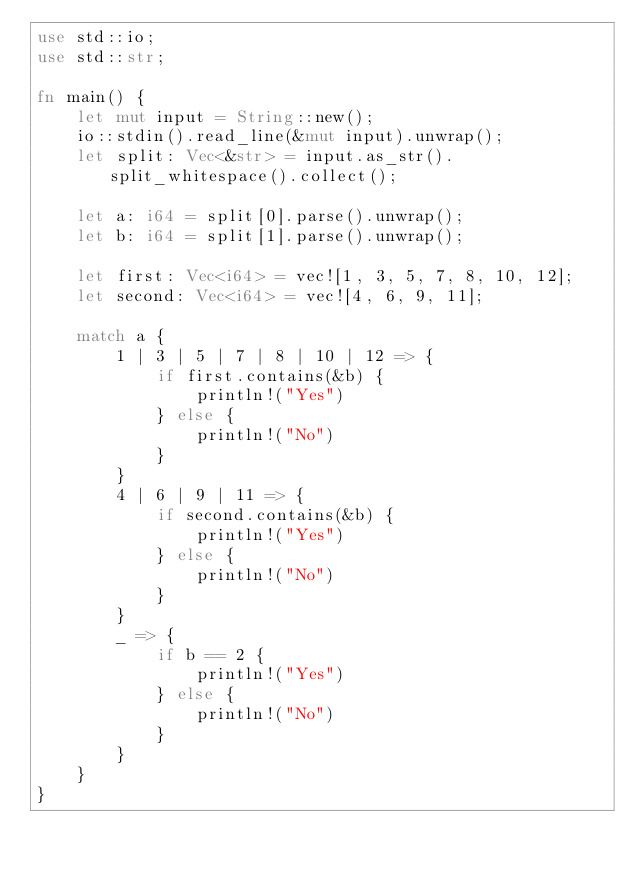<code> <loc_0><loc_0><loc_500><loc_500><_Rust_>use std::io;
use std::str;

fn main() {
    let mut input = String::new();
    io::stdin().read_line(&mut input).unwrap();
    let split: Vec<&str> = input.as_str().split_whitespace().collect();

    let a: i64 = split[0].parse().unwrap();
    let b: i64 = split[1].parse().unwrap();

    let first: Vec<i64> = vec![1, 3, 5, 7, 8, 10, 12];
    let second: Vec<i64> = vec![4, 6, 9, 11];

    match a {
        1 | 3 | 5 | 7 | 8 | 10 | 12 => {
            if first.contains(&b) {
                println!("Yes")
            } else {
                println!("No")
            }
        }
        4 | 6 | 9 | 11 => {
            if second.contains(&b) {
                println!("Yes")
            } else {
                println!("No")
            }
        }
        _ => {
            if b == 2 {
                println!("Yes")
            } else {
                println!("No")
            }
        }
    }
}</code> 